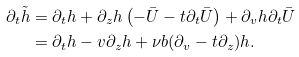Convert formula to latex. <formula><loc_0><loc_0><loc_500><loc_500>\partial _ { t } \tilde { h } & = \partial _ { t } h + \partial _ { z } h \left ( - \bar { U } - t \partial _ { t } \bar { U } \right ) + \partial _ { v } h \partial _ { t } \bar { U } \\ & = \partial _ { t } h - v \partial _ { z } h + \nu b ( \partial _ { v } - t \partial _ { z } ) h .</formula> 